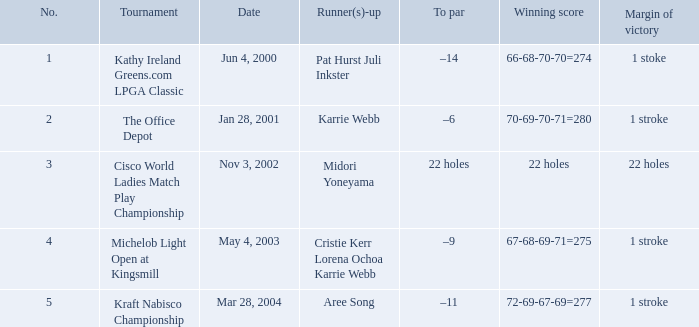Where was the tournament dated nov 3, 2002? Cisco World Ladies Match Play Championship. 